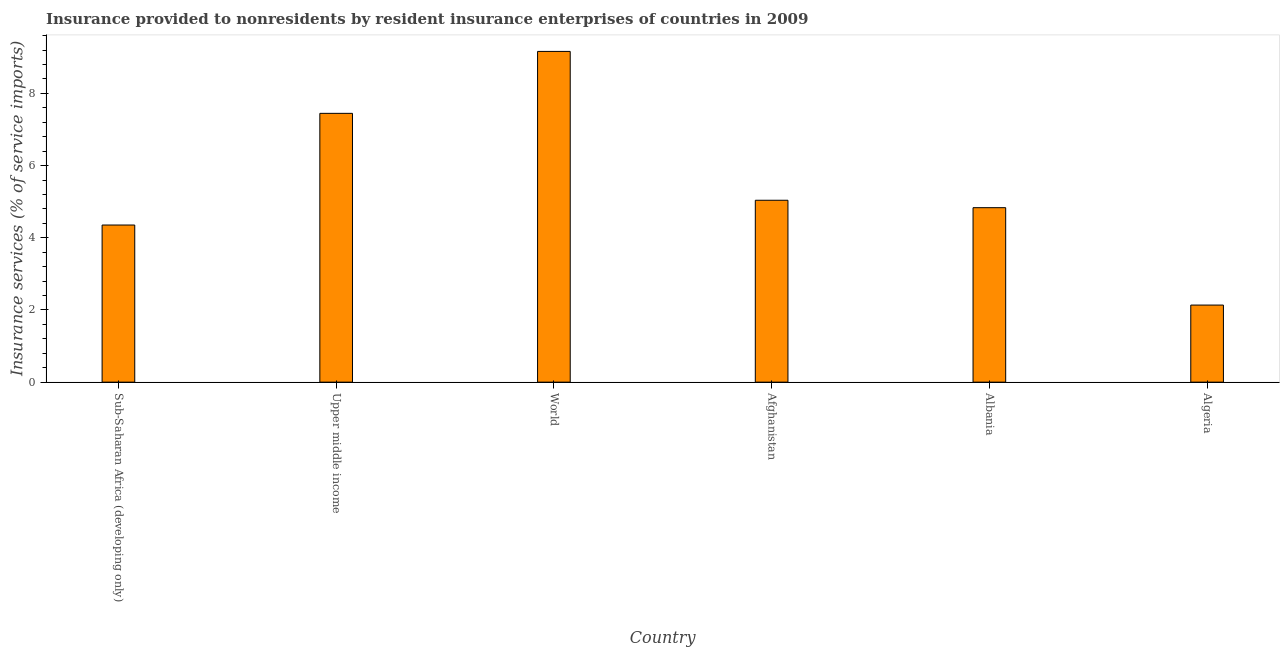Does the graph contain grids?
Provide a succinct answer. No. What is the title of the graph?
Ensure brevity in your answer.  Insurance provided to nonresidents by resident insurance enterprises of countries in 2009. What is the label or title of the X-axis?
Keep it short and to the point. Country. What is the label or title of the Y-axis?
Your answer should be very brief. Insurance services (% of service imports). What is the insurance and financial services in World?
Provide a succinct answer. 9.16. Across all countries, what is the maximum insurance and financial services?
Keep it short and to the point. 9.16. Across all countries, what is the minimum insurance and financial services?
Keep it short and to the point. 2.14. In which country was the insurance and financial services maximum?
Provide a short and direct response. World. In which country was the insurance and financial services minimum?
Provide a short and direct response. Algeria. What is the sum of the insurance and financial services?
Ensure brevity in your answer.  32.97. What is the difference between the insurance and financial services in Afghanistan and Albania?
Make the answer very short. 0.2. What is the average insurance and financial services per country?
Provide a short and direct response. 5.5. What is the median insurance and financial services?
Provide a succinct answer. 4.94. In how many countries, is the insurance and financial services greater than 7.2 %?
Keep it short and to the point. 2. What is the ratio of the insurance and financial services in Afghanistan to that in Upper middle income?
Make the answer very short. 0.68. What is the difference between the highest and the second highest insurance and financial services?
Provide a succinct answer. 1.72. Is the sum of the insurance and financial services in Sub-Saharan Africa (developing only) and World greater than the maximum insurance and financial services across all countries?
Your answer should be compact. Yes. What is the difference between the highest and the lowest insurance and financial services?
Offer a terse response. 7.03. How many bars are there?
Make the answer very short. 6. Are all the bars in the graph horizontal?
Your answer should be compact. No. What is the difference between two consecutive major ticks on the Y-axis?
Your response must be concise. 2. Are the values on the major ticks of Y-axis written in scientific E-notation?
Offer a terse response. No. What is the Insurance services (% of service imports) of Sub-Saharan Africa (developing only)?
Provide a succinct answer. 4.35. What is the Insurance services (% of service imports) of Upper middle income?
Make the answer very short. 7.45. What is the Insurance services (% of service imports) in World?
Your answer should be very brief. 9.16. What is the Insurance services (% of service imports) in Afghanistan?
Make the answer very short. 5.04. What is the Insurance services (% of service imports) of Albania?
Keep it short and to the point. 4.83. What is the Insurance services (% of service imports) of Algeria?
Make the answer very short. 2.14. What is the difference between the Insurance services (% of service imports) in Sub-Saharan Africa (developing only) and Upper middle income?
Offer a terse response. -3.09. What is the difference between the Insurance services (% of service imports) in Sub-Saharan Africa (developing only) and World?
Give a very brief answer. -4.81. What is the difference between the Insurance services (% of service imports) in Sub-Saharan Africa (developing only) and Afghanistan?
Keep it short and to the point. -0.69. What is the difference between the Insurance services (% of service imports) in Sub-Saharan Africa (developing only) and Albania?
Your response must be concise. -0.48. What is the difference between the Insurance services (% of service imports) in Sub-Saharan Africa (developing only) and Algeria?
Ensure brevity in your answer.  2.22. What is the difference between the Insurance services (% of service imports) in Upper middle income and World?
Your answer should be compact. -1.72. What is the difference between the Insurance services (% of service imports) in Upper middle income and Afghanistan?
Your answer should be compact. 2.41. What is the difference between the Insurance services (% of service imports) in Upper middle income and Albania?
Your answer should be very brief. 2.61. What is the difference between the Insurance services (% of service imports) in Upper middle income and Algeria?
Offer a very short reply. 5.31. What is the difference between the Insurance services (% of service imports) in World and Afghanistan?
Offer a terse response. 4.12. What is the difference between the Insurance services (% of service imports) in World and Albania?
Keep it short and to the point. 4.33. What is the difference between the Insurance services (% of service imports) in World and Algeria?
Your answer should be very brief. 7.03. What is the difference between the Insurance services (% of service imports) in Afghanistan and Albania?
Give a very brief answer. 0.21. What is the difference between the Insurance services (% of service imports) in Afghanistan and Algeria?
Offer a terse response. 2.9. What is the difference between the Insurance services (% of service imports) in Albania and Algeria?
Give a very brief answer. 2.7. What is the ratio of the Insurance services (% of service imports) in Sub-Saharan Africa (developing only) to that in Upper middle income?
Your response must be concise. 0.58. What is the ratio of the Insurance services (% of service imports) in Sub-Saharan Africa (developing only) to that in World?
Keep it short and to the point. 0.47. What is the ratio of the Insurance services (% of service imports) in Sub-Saharan Africa (developing only) to that in Afghanistan?
Ensure brevity in your answer.  0.86. What is the ratio of the Insurance services (% of service imports) in Sub-Saharan Africa (developing only) to that in Albania?
Provide a succinct answer. 0.9. What is the ratio of the Insurance services (% of service imports) in Sub-Saharan Africa (developing only) to that in Algeria?
Offer a very short reply. 2.04. What is the ratio of the Insurance services (% of service imports) in Upper middle income to that in World?
Ensure brevity in your answer.  0.81. What is the ratio of the Insurance services (% of service imports) in Upper middle income to that in Afghanistan?
Provide a succinct answer. 1.48. What is the ratio of the Insurance services (% of service imports) in Upper middle income to that in Albania?
Give a very brief answer. 1.54. What is the ratio of the Insurance services (% of service imports) in Upper middle income to that in Algeria?
Keep it short and to the point. 3.49. What is the ratio of the Insurance services (% of service imports) in World to that in Afghanistan?
Give a very brief answer. 1.82. What is the ratio of the Insurance services (% of service imports) in World to that in Albania?
Make the answer very short. 1.9. What is the ratio of the Insurance services (% of service imports) in World to that in Algeria?
Provide a succinct answer. 4.29. What is the ratio of the Insurance services (% of service imports) in Afghanistan to that in Albania?
Give a very brief answer. 1.04. What is the ratio of the Insurance services (% of service imports) in Afghanistan to that in Algeria?
Your answer should be compact. 2.36. What is the ratio of the Insurance services (% of service imports) in Albania to that in Algeria?
Make the answer very short. 2.26. 